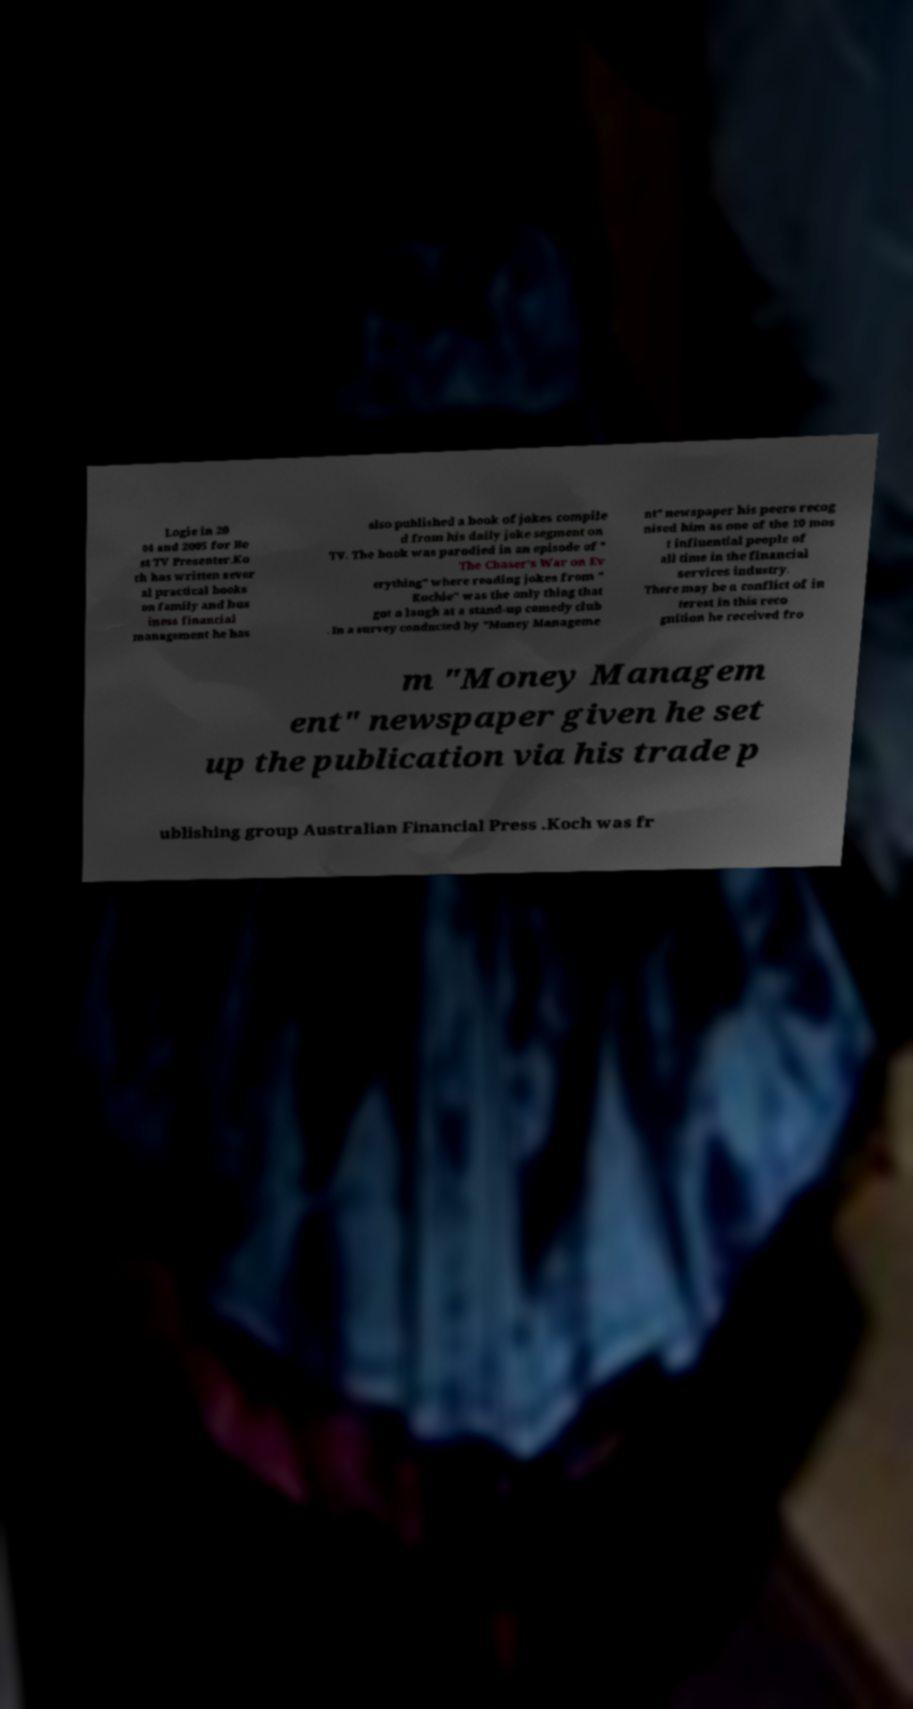Could you extract and type out the text from this image? Logie in 20 04 and 2005 for Be st TV Presenter.Ko ch has written sever al practical books on family and bus iness financial management he has also published a book of jokes compile d from his daily joke segment on TV. The book was parodied in an episode of " The Chaser's War on Ev erything" where reading jokes from " Kochie" was the only thing that got a laugh at a stand-up comedy club . In a survey conducted by "Money Manageme nt" newspaper his peers recog nised him as one of the 10 mos t influential people of all time in the financial services industry. There may be a conflict of in terest in this reco gnition he received fro m "Money Managem ent" newspaper given he set up the publication via his trade p ublishing group Australian Financial Press .Koch was fr 